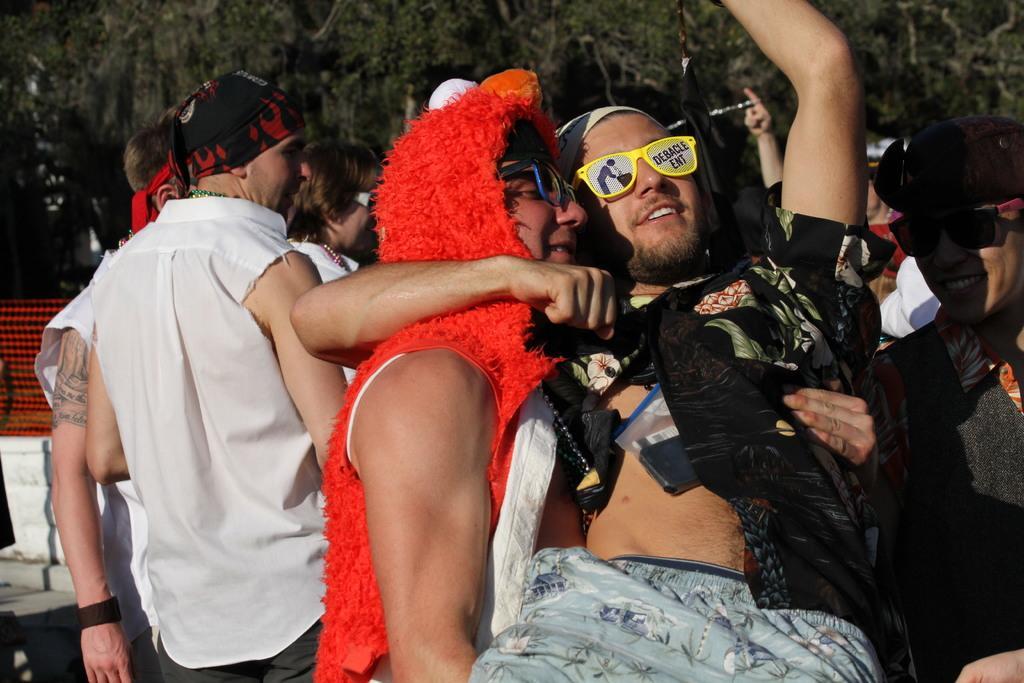Can you describe this image briefly? In the image we can see there are people standing and they are wearing costumes. Behind there are trees. 